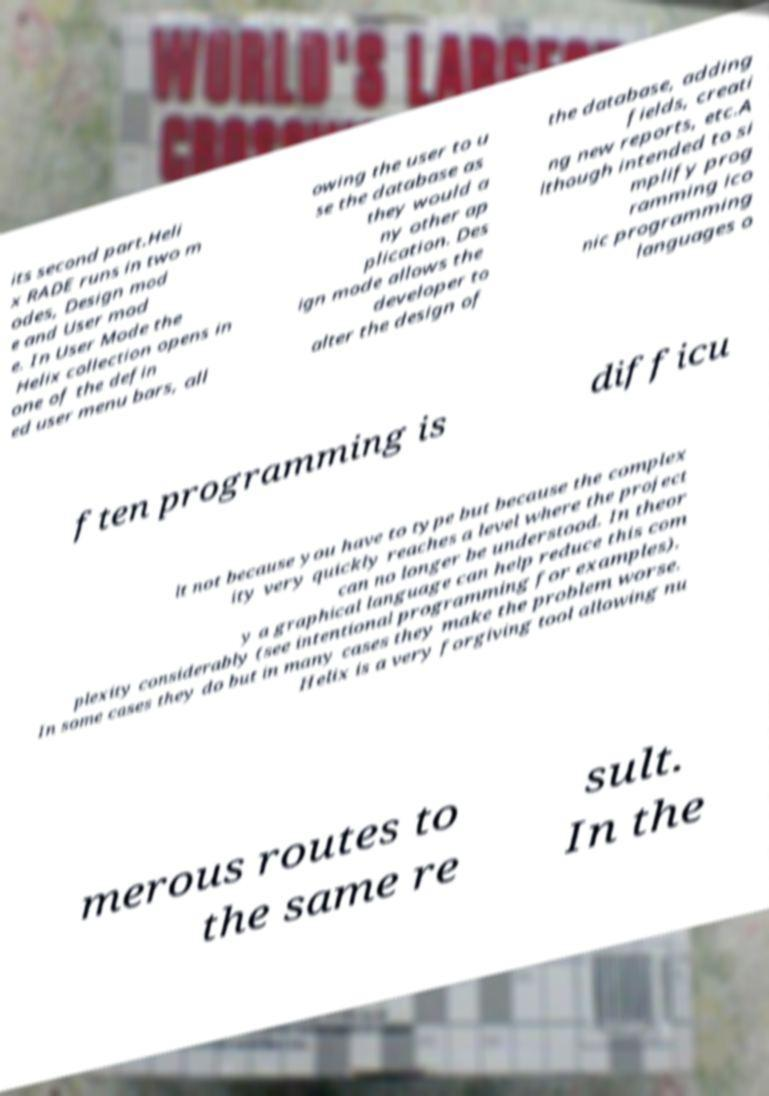I need the written content from this picture converted into text. Can you do that? its second part.Heli x RADE runs in two m odes, Design mod e and User mod e. In User Mode the Helix collection opens in one of the defin ed user menu bars, all owing the user to u se the database as they would a ny other ap plication. Des ign mode allows the developer to alter the design of the database, adding fields, creati ng new reports, etc.A lthough intended to si mplify prog ramming ico nic programming languages o ften programming is difficu lt not because you have to type but because the complex ity very quickly reaches a level where the project can no longer be understood. In theor y a graphical language can help reduce this com plexity considerably (see intentional programming for examples). In some cases they do but in many cases they make the problem worse. Helix is a very forgiving tool allowing nu merous routes to the same re sult. In the 